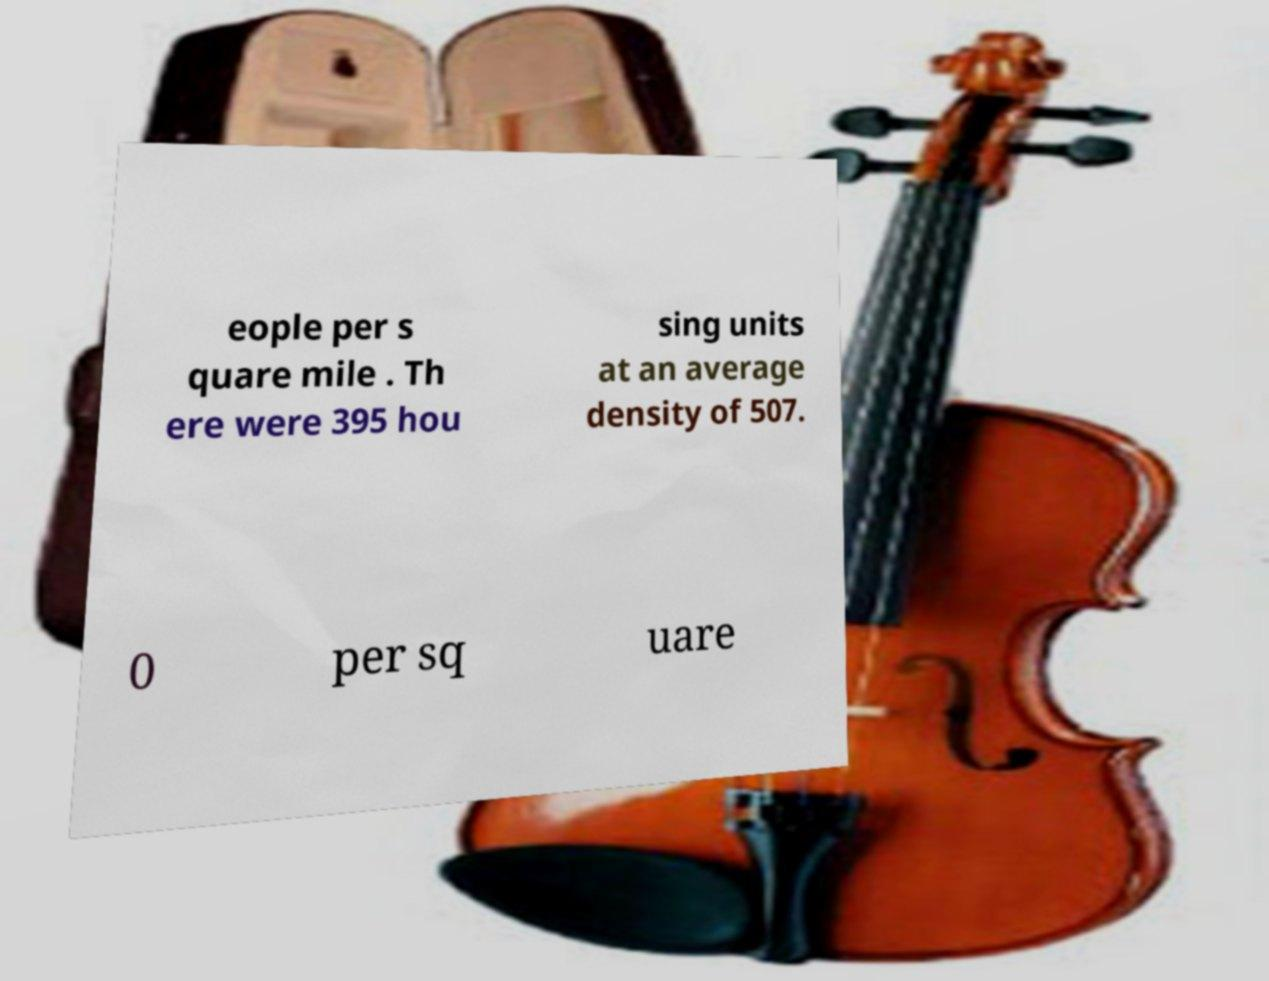Please identify and transcribe the text found in this image. eople per s quare mile . Th ere were 395 hou sing units at an average density of 507. 0 per sq uare 